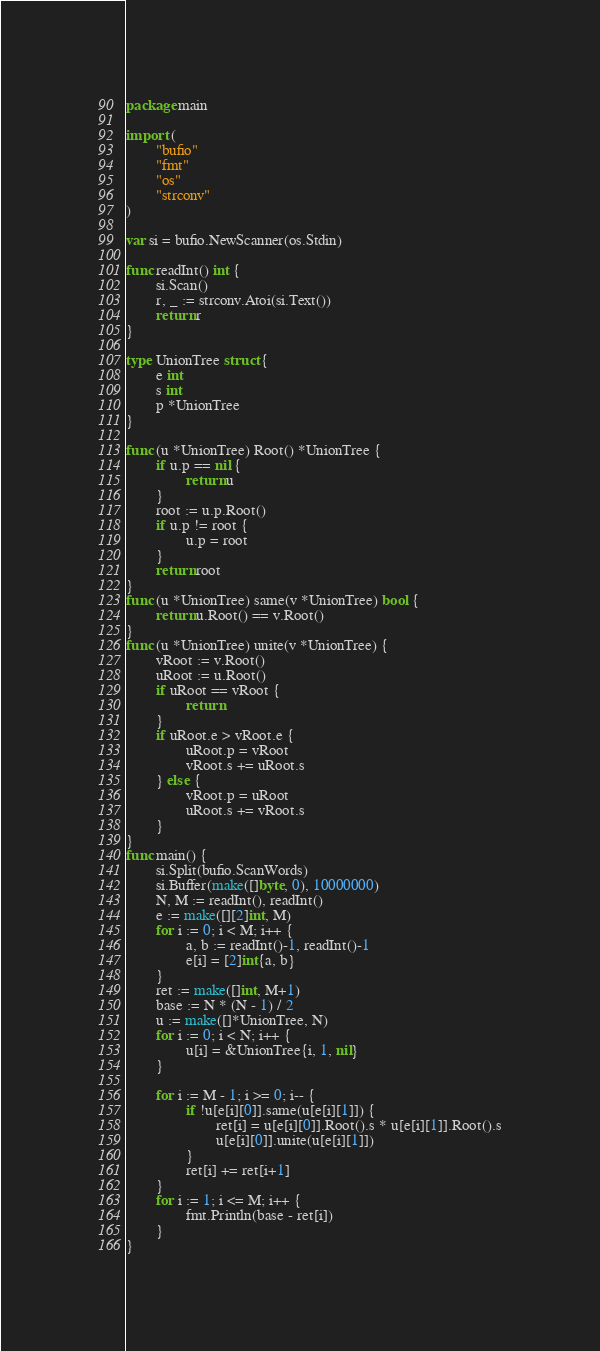Convert code to text. <code><loc_0><loc_0><loc_500><loc_500><_Go_>package main

import (
        "bufio"
        "fmt"
        "os"
        "strconv"
)

var si = bufio.NewScanner(os.Stdin)

func readInt() int {
        si.Scan()
        r, _ := strconv.Atoi(si.Text())
        return r
}

type UnionTree struct {
        e int
        s int
        p *UnionTree
}

func (u *UnionTree) Root() *UnionTree {
        if u.p == nil {
                return u
        }
        root := u.p.Root()
        if u.p != root {
                u.p = root
        }
        return root
}
func (u *UnionTree) same(v *UnionTree) bool {
        return u.Root() == v.Root()
}
func (u *UnionTree) unite(v *UnionTree) {
        vRoot := v.Root()
        uRoot := u.Root()
        if uRoot == vRoot {
                return
        }
        if uRoot.e > vRoot.e {
                uRoot.p = vRoot
                vRoot.s += uRoot.s
        } else {
                vRoot.p = uRoot
                uRoot.s += vRoot.s
        }
}
func main() {
        si.Split(bufio.ScanWords)
        si.Buffer(make([]byte, 0), 10000000)
        N, M := readInt(), readInt()
        e := make([][2]int, M)
        for i := 0; i < M; i++ {
                a, b := readInt()-1, readInt()-1
                e[i] = [2]int{a, b}
        }
        ret := make([]int, M+1)
        base := N * (N - 1) / 2
        u := make([]*UnionTree, N)
        for i := 0; i < N; i++ {
                u[i] = &UnionTree{i, 1, nil}
        }

        for i := M - 1; i >= 0; i-- {
                if !u[e[i][0]].same(u[e[i][1]]) {
                        ret[i] = u[e[i][0]].Root().s * u[e[i][1]].Root().s
                        u[e[i][0]].unite(u[e[i][1]])
                }
                ret[i] += ret[i+1]
        }
        for i := 1; i <= M; i++ {
                fmt.Println(base - ret[i])
        }
}</code> 